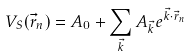Convert formula to latex. <formula><loc_0><loc_0><loc_500><loc_500>V _ { S } ( \vec { r } _ { n } ) = A _ { 0 } + \sum _ { \vec { k } } A _ { \vec { k } } e ^ { \vec { k } \cdot \vec { r } _ { n } }</formula> 